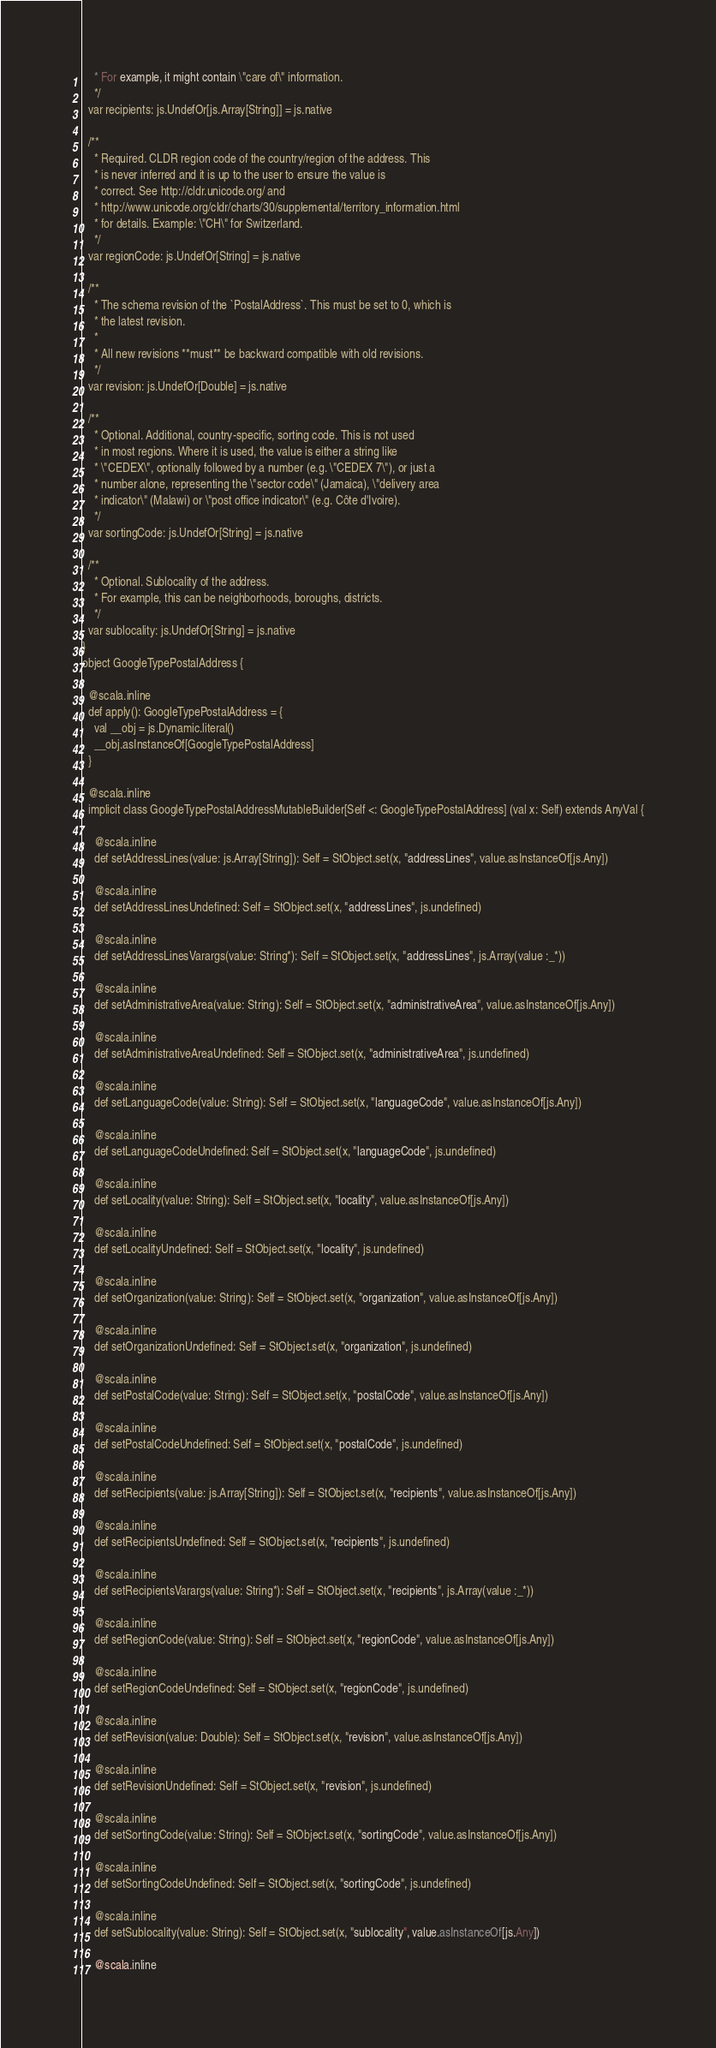Convert code to text. <code><loc_0><loc_0><loc_500><loc_500><_Scala_>    * For example, it might contain \"care of\" information.
    */
  var recipients: js.UndefOr[js.Array[String]] = js.native
  
  /**
    * Required. CLDR region code of the country/region of the address. This
    * is never inferred and it is up to the user to ensure the value is
    * correct. See http://cldr.unicode.org/ and
    * http://www.unicode.org/cldr/charts/30/supplemental/territory_information.html
    * for details. Example: \"CH\" for Switzerland.
    */
  var regionCode: js.UndefOr[String] = js.native
  
  /**
    * The schema revision of the `PostalAddress`. This must be set to 0, which is
    * the latest revision.
    *
    * All new revisions **must** be backward compatible with old revisions.
    */
  var revision: js.UndefOr[Double] = js.native
  
  /**
    * Optional. Additional, country-specific, sorting code. This is not used
    * in most regions. Where it is used, the value is either a string like
    * \"CEDEX\", optionally followed by a number (e.g. \"CEDEX 7\"), or just a
    * number alone, representing the \"sector code\" (Jamaica), \"delivery area
    * indicator\" (Malawi) or \"post office indicator\" (e.g. Côte d'Ivoire).
    */
  var sortingCode: js.UndefOr[String] = js.native
  
  /**
    * Optional. Sublocality of the address.
    * For example, this can be neighborhoods, boroughs, districts.
    */
  var sublocality: js.UndefOr[String] = js.native
}
object GoogleTypePostalAddress {
  
  @scala.inline
  def apply(): GoogleTypePostalAddress = {
    val __obj = js.Dynamic.literal()
    __obj.asInstanceOf[GoogleTypePostalAddress]
  }
  
  @scala.inline
  implicit class GoogleTypePostalAddressMutableBuilder[Self <: GoogleTypePostalAddress] (val x: Self) extends AnyVal {
    
    @scala.inline
    def setAddressLines(value: js.Array[String]): Self = StObject.set(x, "addressLines", value.asInstanceOf[js.Any])
    
    @scala.inline
    def setAddressLinesUndefined: Self = StObject.set(x, "addressLines", js.undefined)
    
    @scala.inline
    def setAddressLinesVarargs(value: String*): Self = StObject.set(x, "addressLines", js.Array(value :_*))
    
    @scala.inline
    def setAdministrativeArea(value: String): Self = StObject.set(x, "administrativeArea", value.asInstanceOf[js.Any])
    
    @scala.inline
    def setAdministrativeAreaUndefined: Self = StObject.set(x, "administrativeArea", js.undefined)
    
    @scala.inline
    def setLanguageCode(value: String): Self = StObject.set(x, "languageCode", value.asInstanceOf[js.Any])
    
    @scala.inline
    def setLanguageCodeUndefined: Self = StObject.set(x, "languageCode", js.undefined)
    
    @scala.inline
    def setLocality(value: String): Self = StObject.set(x, "locality", value.asInstanceOf[js.Any])
    
    @scala.inline
    def setLocalityUndefined: Self = StObject.set(x, "locality", js.undefined)
    
    @scala.inline
    def setOrganization(value: String): Self = StObject.set(x, "organization", value.asInstanceOf[js.Any])
    
    @scala.inline
    def setOrganizationUndefined: Self = StObject.set(x, "organization", js.undefined)
    
    @scala.inline
    def setPostalCode(value: String): Self = StObject.set(x, "postalCode", value.asInstanceOf[js.Any])
    
    @scala.inline
    def setPostalCodeUndefined: Self = StObject.set(x, "postalCode", js.undefined)
    
    @scala.inline
    def setRecipients(value: js.Array[String]): Self = StObject.set(x, "recipients", value.asInstanceOf[js.Any])
    
    @scala.inline
    def setRecipientsUndefined: Self = StObject.set(x, "recipients", js.undefined)
    
    @scala.inline
    def setRecipientsVarargs(value: String*): Self = StObject.set(x, "recipients", js.Array(value :_*))
    
    @scala.inline
    def setRegionCode(value: String): Self = StObject.set(x, "regionCode", value.asInstanceOf[js.Any])
    
    @scala.inline
    def setRegionCodeUndefined: Self = StObject.set(x, "regionCode", js.undefined)
    
    @scala.inline
    def setRevision(value: Double): Self = StObject.set(x, "revision", value.asInstanceOf[js.Any])
    
    @scala.inline
    def setRevisionUndefined: Self = StObject.set(x, "revision", js.undefined)
    
    @scala.inline
    def setSortingCode(value: String): Self = StObject.set(x, "sortingCode", value.asInstanceOf[js.Any])
    
    @scala.inline
    def setSortingCodeUndefined: Self = StObject.set(x, "sortingCode", js.undefined)
    
    @scala.inline
    def setSublocality(value: String): Self = StObject.set(x, "sublocality", value.asInstanceOf[js.Any])
    
    @scala.inline</code> 